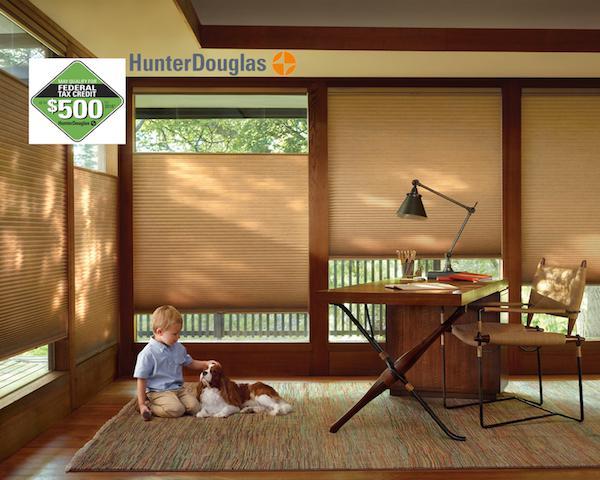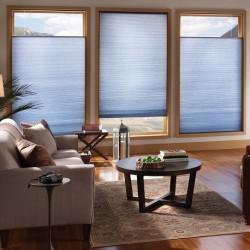The first image is the image on the left, the second image is the image on the right. For the images shown, is this caption "There are exactly three shades in the right image." true? Answer yes or no. Yes. The first image is the image on the left, the second image is the image on the right. Assess this claim about the two images: "There are eight blinds.". Correct or not? Answer yes or no. Yes. 